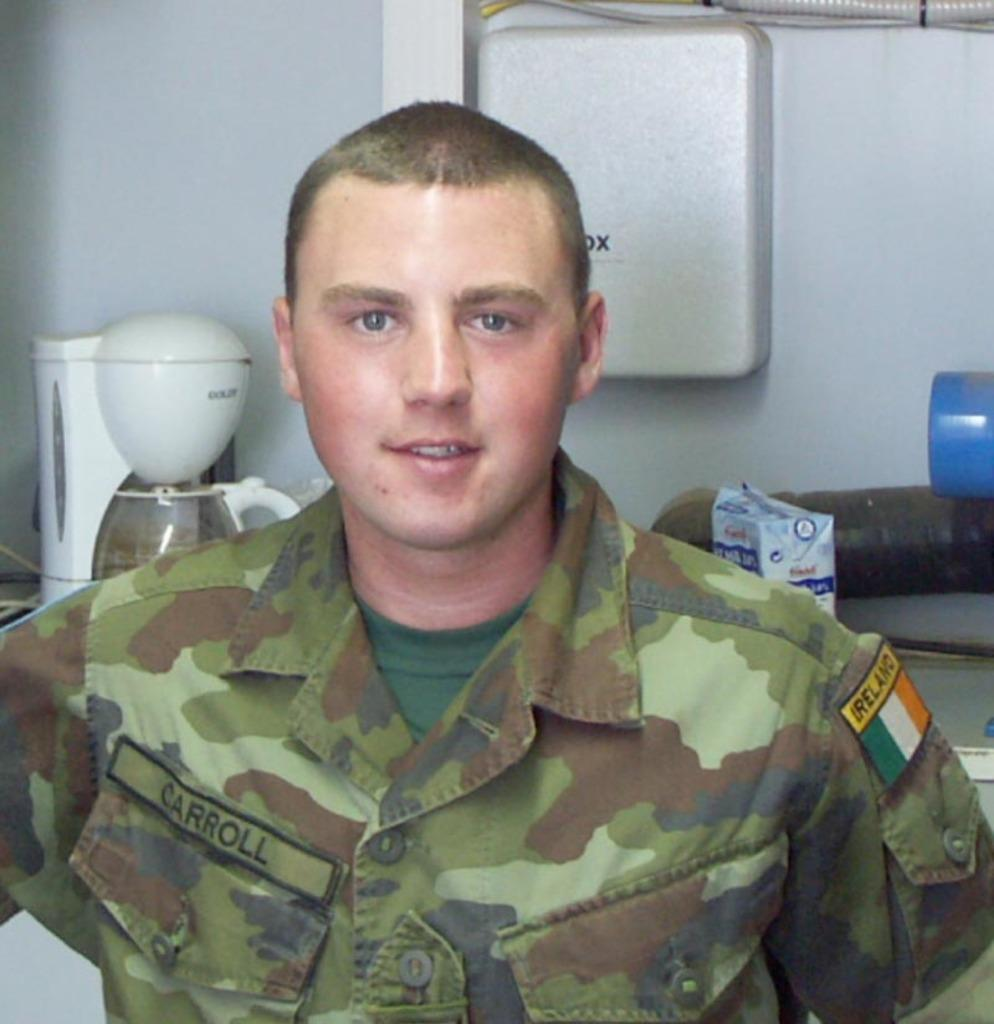Provide a one-sentence caption for the provided image. Soldier Carroll is from the country of ireland. 